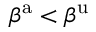Convert formula to latex. <formula><loc_0><loc_0><loc_500><loc_500>\beta ^ { a } < \beta ^ { u }</formula> 